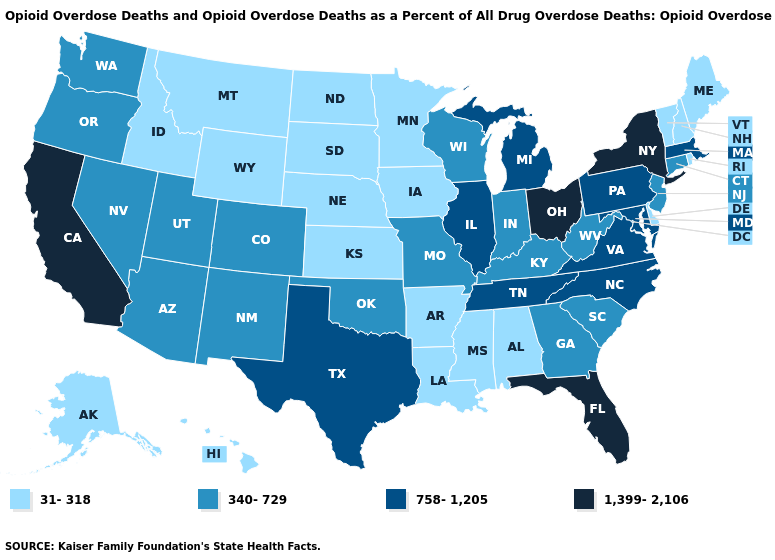What is the value of Washington?
Short answer required. 340-729. Does Delaware have the highest value in the USA?
Write a very short answer. No. Name the states that have a value in the range 340-729?
Write a very short answer. Arizona, Colorado, Connecticut, Georgia, Indiana, Kentucky, Missouri, Nevada, New Jersey, New Mexico, Oklahoma, Oregon, South Carolina, Utah, Washington, West Virginia, Wisconsin. Name the states that have a value in the range 758-1,205?
Answer briefly. Illinois, Maryland, Massachusetts, Michigan, North Carolina, Pennsylvania, Tennessee, Texas, Virginia. What is the value of Utah?
Write a very short answer. 340-729. Which states have the lowest value in the USA?
Keep it brief. Alabama, Alaska, Arkansas, Delaware, Hawaii, Idaho, Iowa, Kansas, Louisiana, Maine, Minnesota, Mississippi, Montana, Nebraska, New Hampshire, North Dakota, Rhode Island, South Dakota, Vermont, Wyoming. Name the states that have a value in the range 1,399-2,106?
Keep it brief. California, Florida, New York, Ohio. What is the highest value in the South ?
Answer briefly. 1,399-2,106. Name the states that have a value in the range 340-729?
Write a very short answer. Arizona, Colorado, Connecticut, Georgia, Indiana, Kentucky, Missouri, Nevada, New Jersey, New Mexico, Oklahoma, Oregon, South Carolina, Utah, Washington, West Virginia, Wisconsin. What is the value of Washington?
Answer briefly. 340-729. What is the lowest value in states that border Iowa?
Answer briefly. 31-318. What is the value of Vermont?
Give a very brief answer. 31-318. What is the highest value in the Northeast ?
Give a very brief answer. 1,399-2,106. What is the lowest value in states that border Delaware?
Write a very short answer. 340-729. Which states have the lowest value in the USA?
Short answer required. Alabama, Alaska, Arkansas, Delaware, Hawaii, Idaho, Iowa, Kansas, Louisiana, Maine, Minnesota, Mississippi, Montana, Nebraska, New Hampshire, North Dakota, Rhode Island, South Dakota, Vermont, Wyoming. 